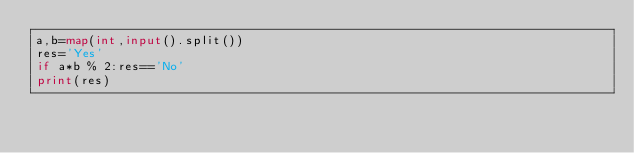<code> <loc_0><loc_0><loc_500><loc_500><_Python_>a,b=map(int,input().split())
res='Yes'
if a*b % 2:res=='No'
print(res)</code> 